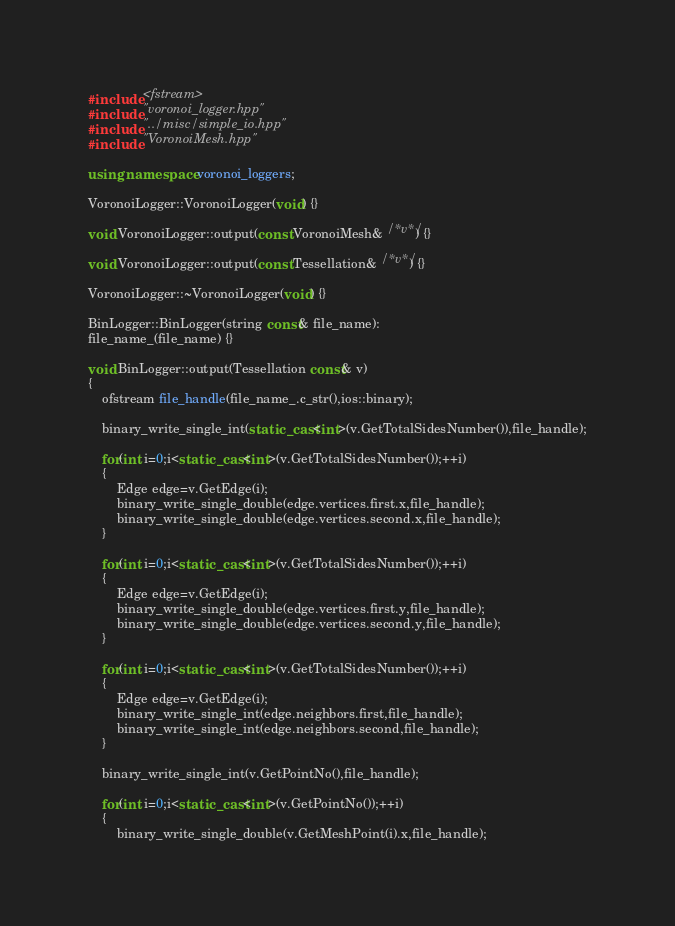Convert code to text. <code><loc_0><loc_0><loc_500><loc_500><_C++_>#include <fstream>
#include "voronoi_logger.hpp"
#include "../misc/simple_io.hpp"
#include "VoronoiMesh.hpp"

using namespace voronoi_loggers;

VoronoiLogger::VoronoiLogger(void) {}

void VoronoiLogger::output(const VoronoiMesh& /*v*/) {}

void VoronoiLogger::output(const Tessellation& /*v*/) {}

VoronoiLogger::~VoronoiLogger(void) {}

BinLogger::BinLogger(string const& file_name):
file_name_(file_name) {}

void BinLogger::output(Tessellation const& v)
{
	ofstream file_handle(file_name_.c_str(),ios::binary);

	binary_write_single_int(static_cast<int>(v.GetTotalSidesNumber()),file_handle);

	for(int i=0;i<static_cast<int>(v.GetTotalSidesNumber());++i)
	{
		Edge edge=v.GetEdge(i);
		binary_write_single_double(edge.vertices.first.x,file_handle);
		binary_write_single_double(edge.vertices.second.x,file_handle);
	}

	for(int i=0;i<static_cast<int>(v.GetTotalSidesNumber());++i)
	{
		Edge edge=v.GetEdge(i);
		binary_write_single_double(edge.vertices.first.y,file_handle);
		binary_write_single_double(edge.vertices.second.y,file_handle);
	}

	for(int i=0;i<static_cast<int>(v.GetTotalSidesNumber());++i)
	{
		Edge edge=v.GetEdge(i);
		binary_write_single_int(edge.neighbors.first,file_handle);
		binary_write_single_int(edge.neighbors.second,file_handle);
	}

	binary_write_single_int(v.GetPointNo(),file_handle);

	for(int i=0;i<static_cast<int>(v.GetPointNo());++i)
	{
		binary_write_single_double(v.GetMeshPoint(i).x,file_handle);</code> 